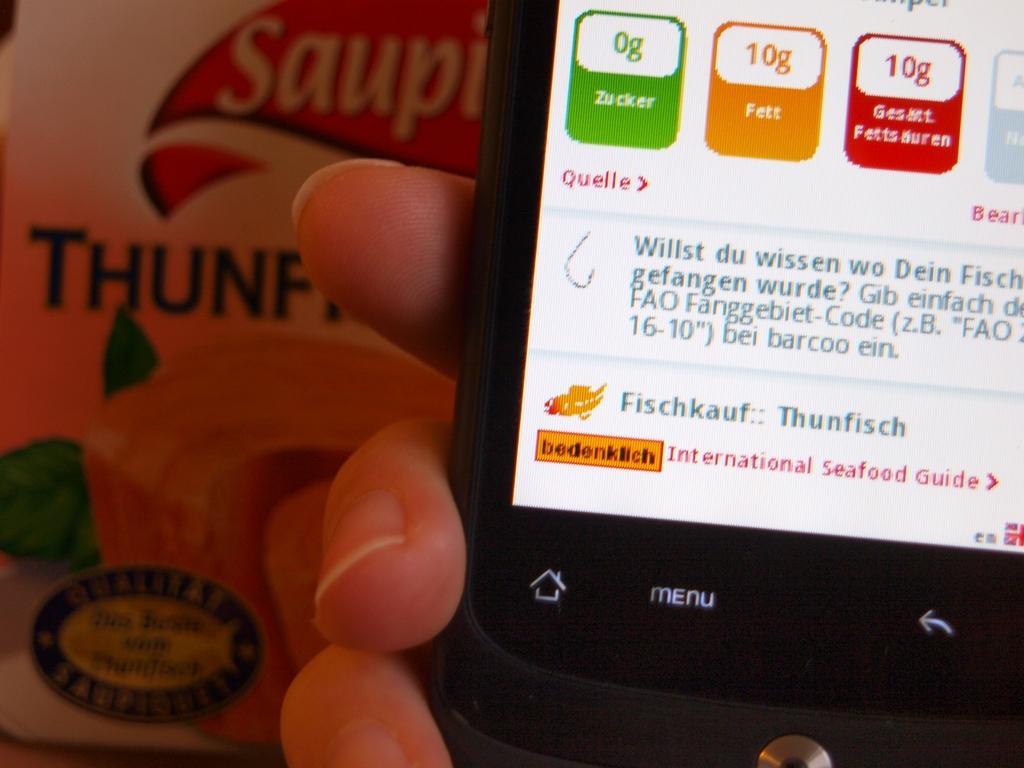<image>
Give a short and clear explanation of the subsequent image. A man holding up a black phone with the menu button illuminated. 